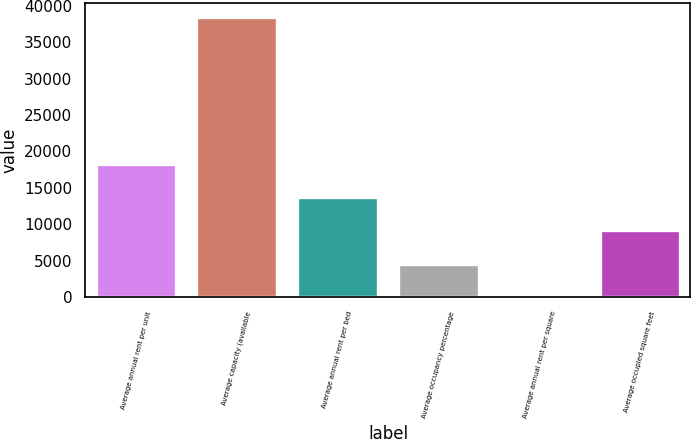Convert chart. <chart><loc_0><loc_0><loc_500><loc_500><bar_chart><fcel>Average annual rent per unit<fcel>Average capacity (available<fcel>Average annual rent per bed<fcel>Average occupancy percentage<fcel>Average annual rent per square<fcel>Average occupied square feet<nl><fcel>18301.2<fcel>38441<fcel>13737.4<fcel>4609.8<fcel>46<fcel>9173.6<nl></chart> 